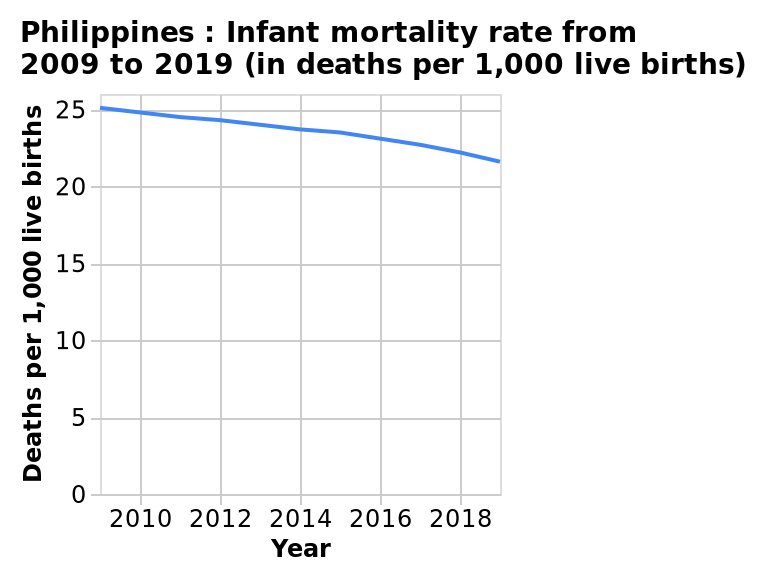<image>
What was the range of the infant mortality rate in the Philippines between 2015 and 2019?  The range of the infant mortality rate in the Philippines between 2015 and 2019 was approximately 21 to 24 per 1000 live births. Offer a thorough analysis of the image. The infant mortality rate of the Philippines drops at a steady rate from 25 per 1000 live births in 2009 to between 23 and 24 per 1000 live births in 2015.  From 2015 this number drops more sharply to around 21/22 in 2019. In what country does the line plot depict the infant mortality rate? The line plot depicts the infant mortality rate in the Philippines. 